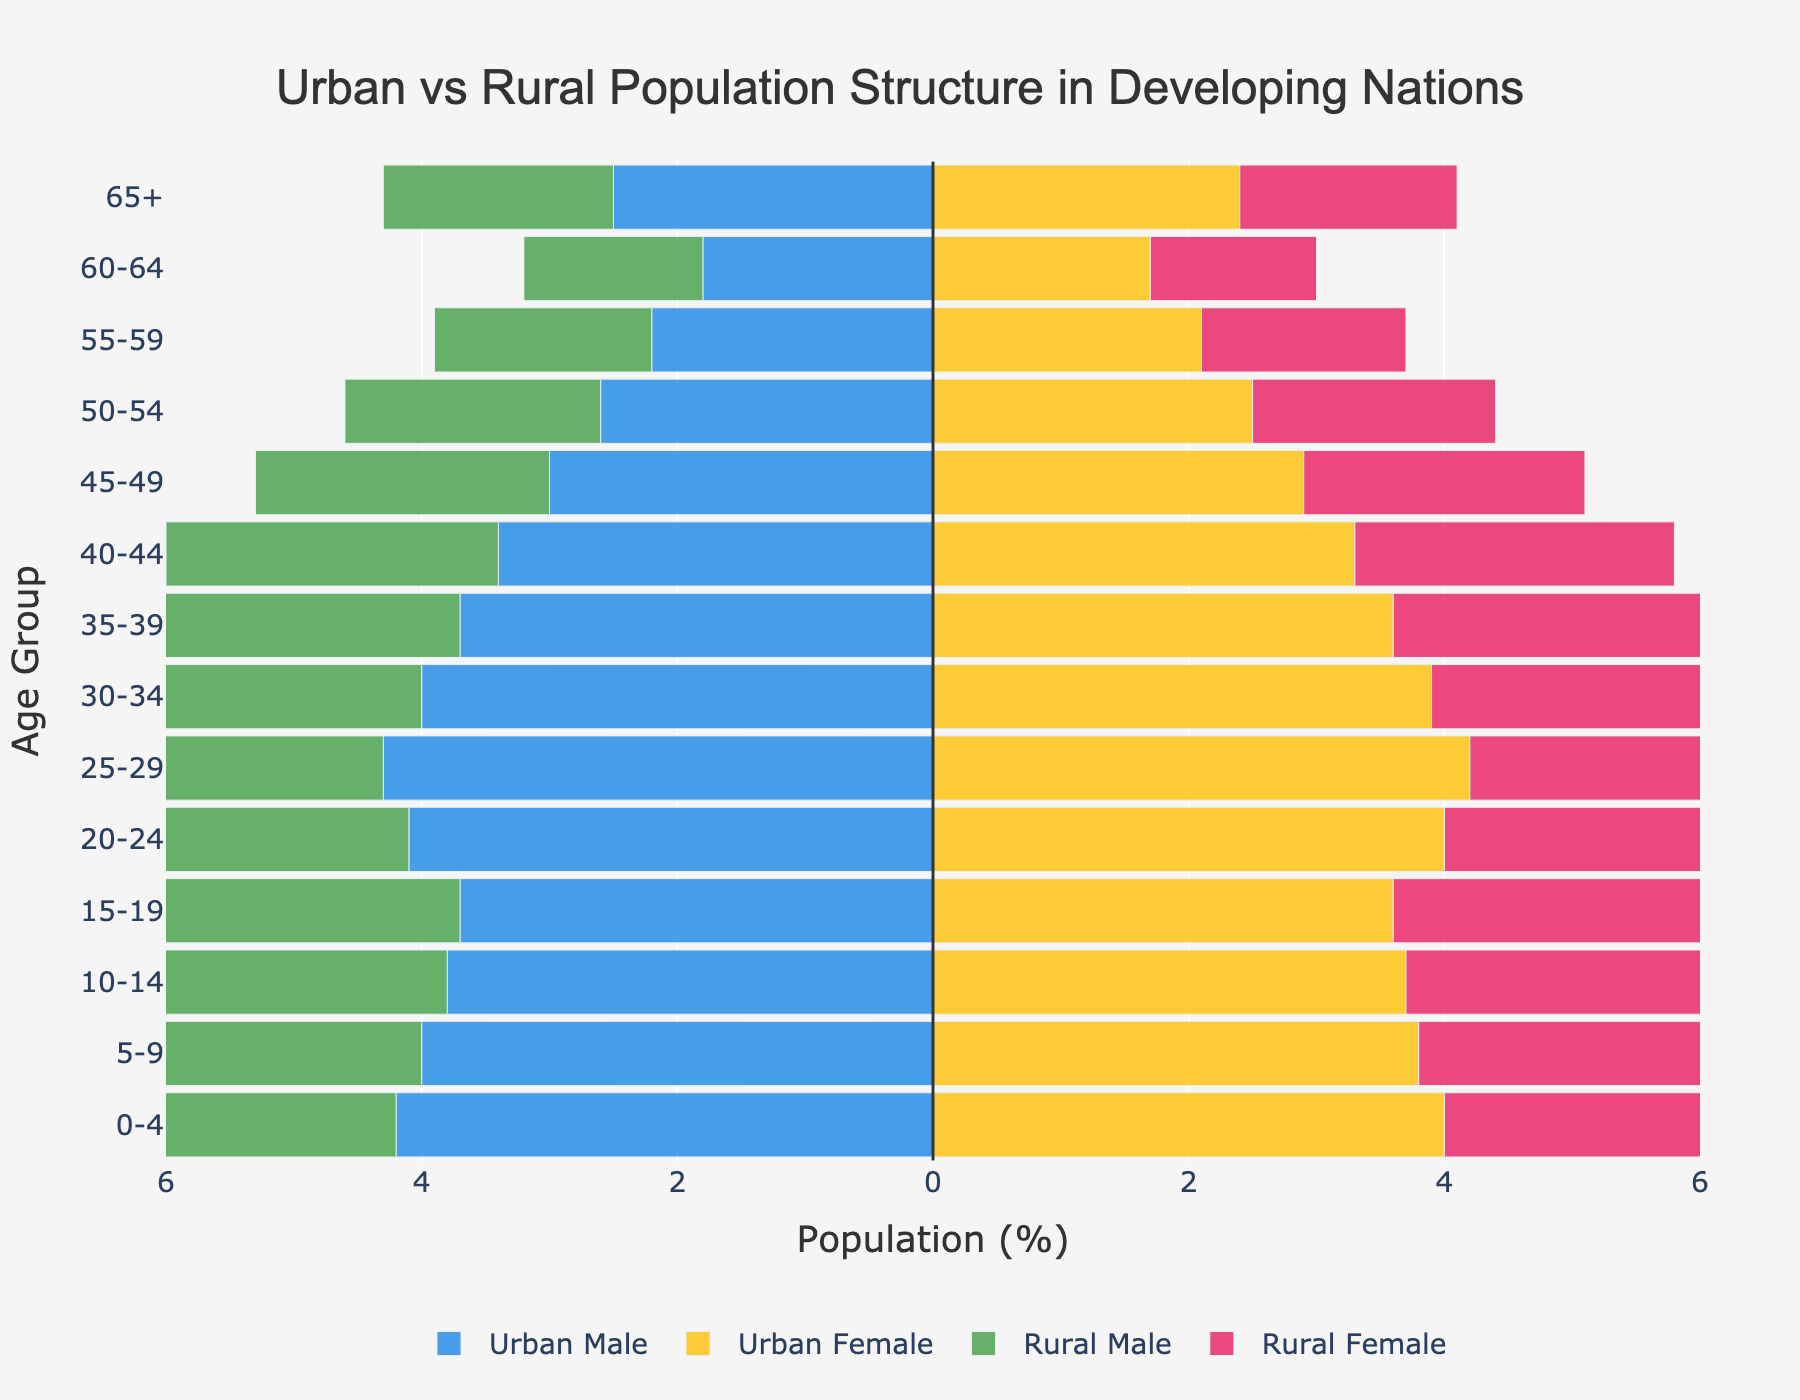What is the title of the figure? The title of the figure is located at the top center of the plot. It reads, "Urban vs Rural Population Structure in Developing Nations."
Answer: Urban vs Rural Population Structure in Developing Nations What is the percentage of Urban Male in the 25-29 age group? To find this, refer to the horizontal bar for Urban Male in the 25-29 age group. The bar extends to -4.3%. The negative sign indicates it's Male for the Urban population.
Answer: 4.3% Which age group has the highest percentage of Rural Female population? Look at the Rural Female bars across all age groups to find the longest bar. The 0-4 age group has the longest bar for Rural Female, indicating 5.3%.
Answer: 0-4 How does the Urban Female population in the 20-24 age group compare to the Rural Female population in the same age group? Compare the two bars for Urban Female and Rural Female in the 20-24 age group. Urban Female is 4.0%, and Rural Female is 3.8%.
Answer: Urban Female is higher Which population category has a higher percentage for ages 65+ - Urban Male or Rural Male? Compare the bars for Urban Male and Rural Male in the 65+ age group. Urban Male is -2.5%, and Rural Male is -1.8%. The negative sign only indicates male population.
Answer: Urban Male What is the combined percentage of Urban Female and Rural Female in the 10-14 age group? Add the Urban Female (3.7%) and Rural Female (4.7%) percentages in the 10-14 age group. 3.7% + 4.7% = 8.4%.
Answer: 8.4% 